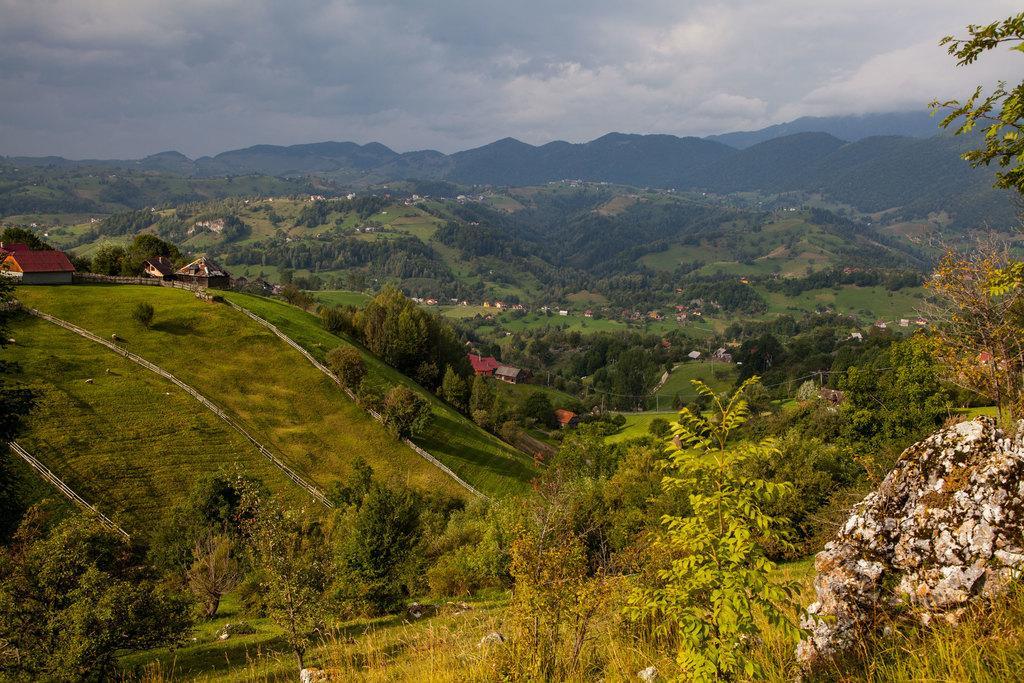Please provide a concise description of this image. In this image there are plants, grass, rocks, stones, houses, wooden fences, trees and mountains, at the top of the image there are clouds in the sky. 